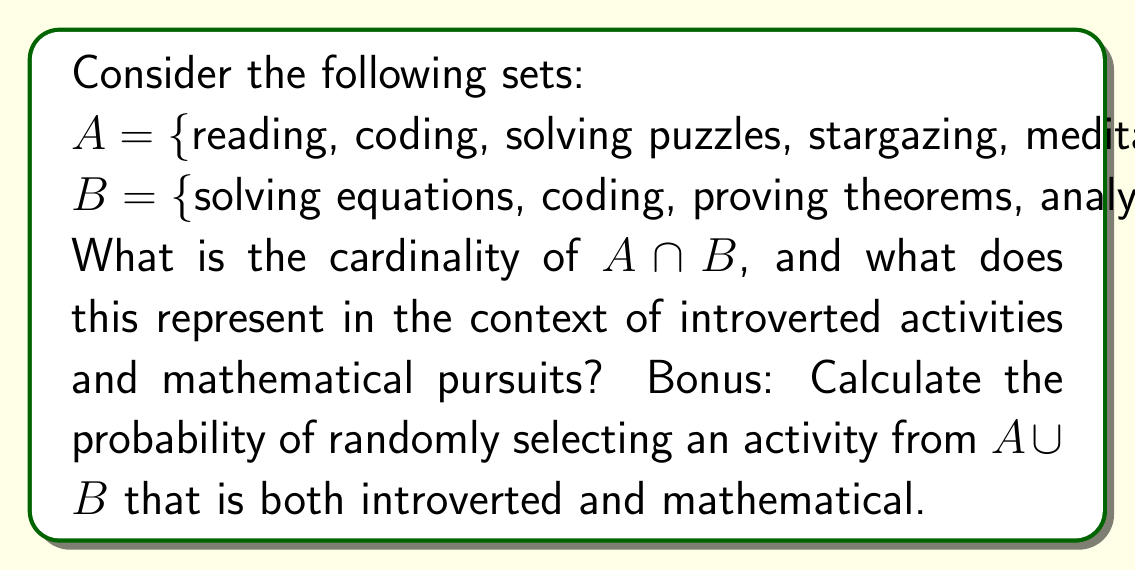Can you answer this question? Let's approach this step-by-step:

1) First, we need to find $A \cap B$:
   $A \cap B = \{$coding, solving puzzles$\}$

2) The cardinality of $A \cap B$ is:
   $|A \cap B| = 2$

3) This represents the number of activities that are both introverted and mathematical.

4) For the bonus question, we need to:
   a) Find $A \cup B$
   b) Calculate $|A \cup B|$
   c) Calculate the probability

   a) $A \cup B = \{$reading, coding, solving puzzles, stargazing, meditating, solving equations, proving theorems, analyzing data$\}$
   
   b) $|A \cup B| = 8$

   c) Probability = $\frac{|A \cap B|}{|A \cup B|} = \frac{2}{8} = \frac{1}{4}$

Therefore, the probability of randomly selecting an activity from $A \cup B$ that is both introverted and mathematical is $\frac{1}{4}$ or 25%.
Answer: The cardinality of $A \cap B$ is 2, representing the number of activities that are both introverted and mathematical. The probability of randomly selecting an activity from $A \cup B$ that is both introverted and mathematical is $\frac{1}{4}$ or 25%. 